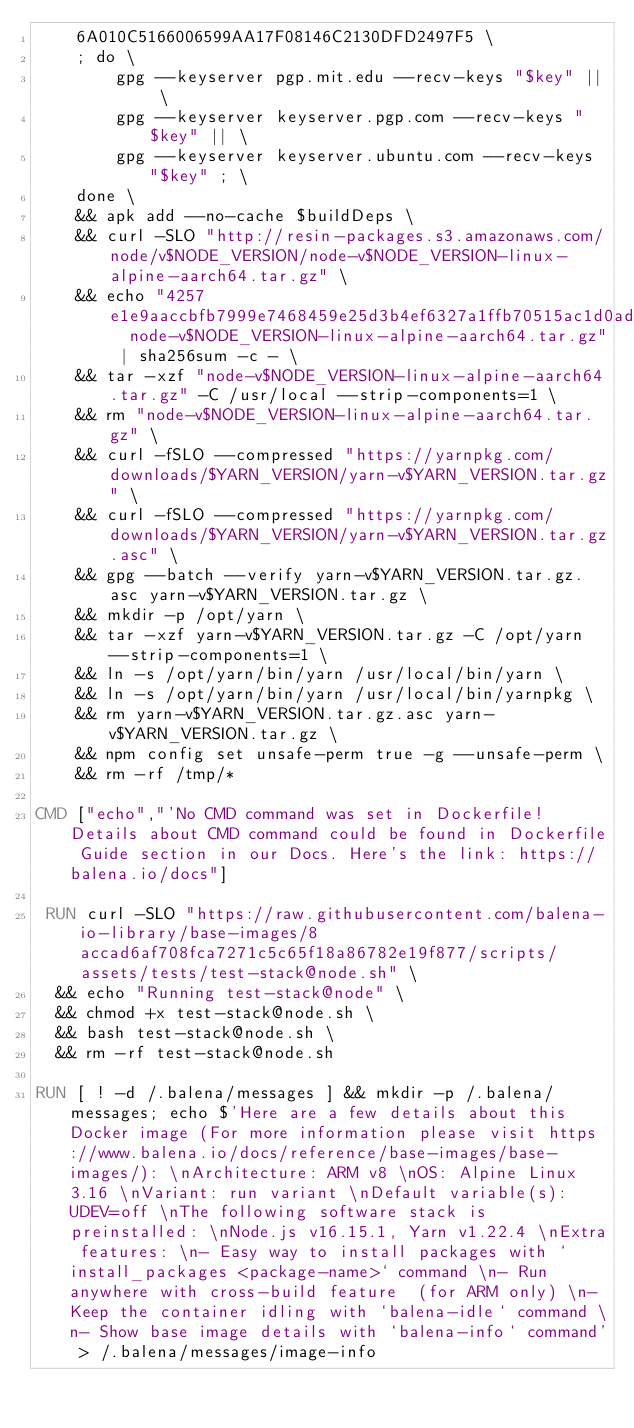<code> <loc_0><loc_0><loc_500><loc_500><_Dockerfile_>	6A010C5166006599AA17F08146C2130DFD2497F5 \
	; do \
		gpg --keyserver pgp.mit.edu --recv-keys "$key" || \
		gpg --keyserver keyserver.pgp.com --recv-keys "$key" || \
		gpg --keyserver keyserver.ubuntu.com --recv-keys "$key" ; \
	done \
	&& apk add --no-cache $buildDeps \
	&& curl -SLO "http://resin-packages.s3.amazonaws.com/node/v$NODE_VERSION/node-v$NODE_VERSION-linux-alpine-aarch64.tar.gz" \
	&& echo "4257e1e9aaccbfb7999e7468459e25d3b4ef6327a1ffb70515ac1d0ad3da8a26  node-v$NODE_VERSION-linux-alpine-aarch64.tar.gz" | sha256sum -c - \
	&& tar -xzf "node-v$NODE_VERSION-linux-alpine-aarch64.tar.gz" -C /usr/local --strip-components=1 \
	&& rm "node-v$NODE_VERSION-linux-alpine-aarch64.tar.gz" \
	&& curl -fSLO --compressed "https://yarnpkg.com/downloads/$YARN_VERSION/yarn-v$YARN_VERSION.tar.gz" \
	&& curl -fSLO --compressed "https://yarnpkg.com/downloads/$YARN_VERSION/yarn-v$YARN_VERSION.tar.gz.asc" \
	&& gpg --batch --verify yarn-v$YARN_VERSION.tar.gz.asc yarn-v$YARN_VERSION.tar.gz \
	&& mkdir -p /opt/yarn \
	&& tar -xzf yarn-v$YARN_VERSION.tar.gz -C /opt/yarn --strip-components=1 \
	&& ln -s /opt/yarn/bin/yarn /usr/local/bin/yarn \
	&& ln -s /opt/yarn/bin/yarn /usr/local/bin/yarnpkg \
	&& rm yarn-v$YARN_VERSION.tar.gz.asc yarn-v$YARN_VERSION.tar.gz \
	&& npm config set unsafe-perm true -g --unsafe-perm \
	&& rm -rf /tmp/*

CMD ["echo","'No CMD command was set in Dockerfile! Details about CMD command could be found in Dockerfile Guide section in our Docs. Here's the link: https://balena.io/docs"]

 RUN curl -SLO "https://raw.githubusercontent.com/balena-io-library/base-images/8accad6af708fca7271c5c65f18a86782e19f877/scripts/assets/tests/test-stack@node.sh" \
  && echo "Running test-stack@node" \
  && chmod +x test-stack@node.sh \
  && bash test-stack@node.sh \
  && rm -rf test-stack@node.sh 

RUN [ ! -d /.balena/messages ] && mkdir -p /.balena/messages; echo $'Here are a few details about this Docker image (For more information please visit https://www.balena.io/docs/reference/base-images/base-images/): \nArchitecture: ARM v8 \nOS: Alpine Linux 3.16 \nVariant: run variant \nDefault variable(s): UDEV=off \nThe following software stack is preinstalled: \nNode.js v16.15.1, Yarn v1.22.4 \nExtra features: \n- Easy way to install packages with `install_packages <package-name>` command \n- Run anywhere with cross-build feature  (for ARM only) \n- Keep the container idling with `balena-idle` command \n- Show base image details with `balena-info` command' > /.balena/messages/image-info</code> 